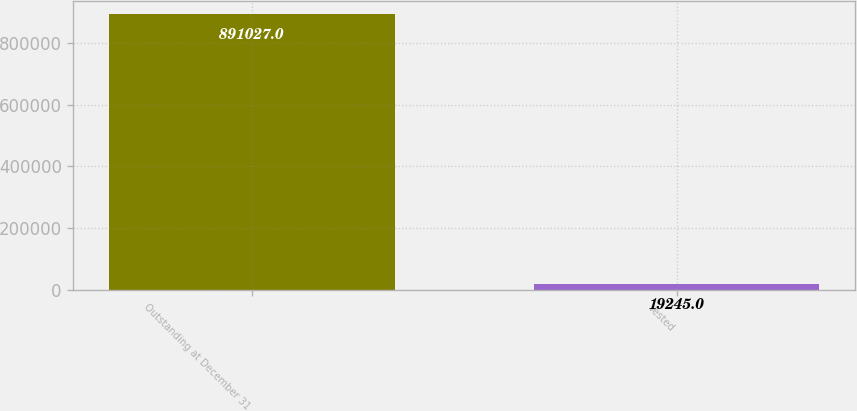Convert chart to OTSL. <chart><loc_0><loc_0><loc_500><loc_500><bar_chart><fcel>Outstanding at December 31<fcel>Vested<nl><fcel>891027<fcel>19245<nl></chart> 